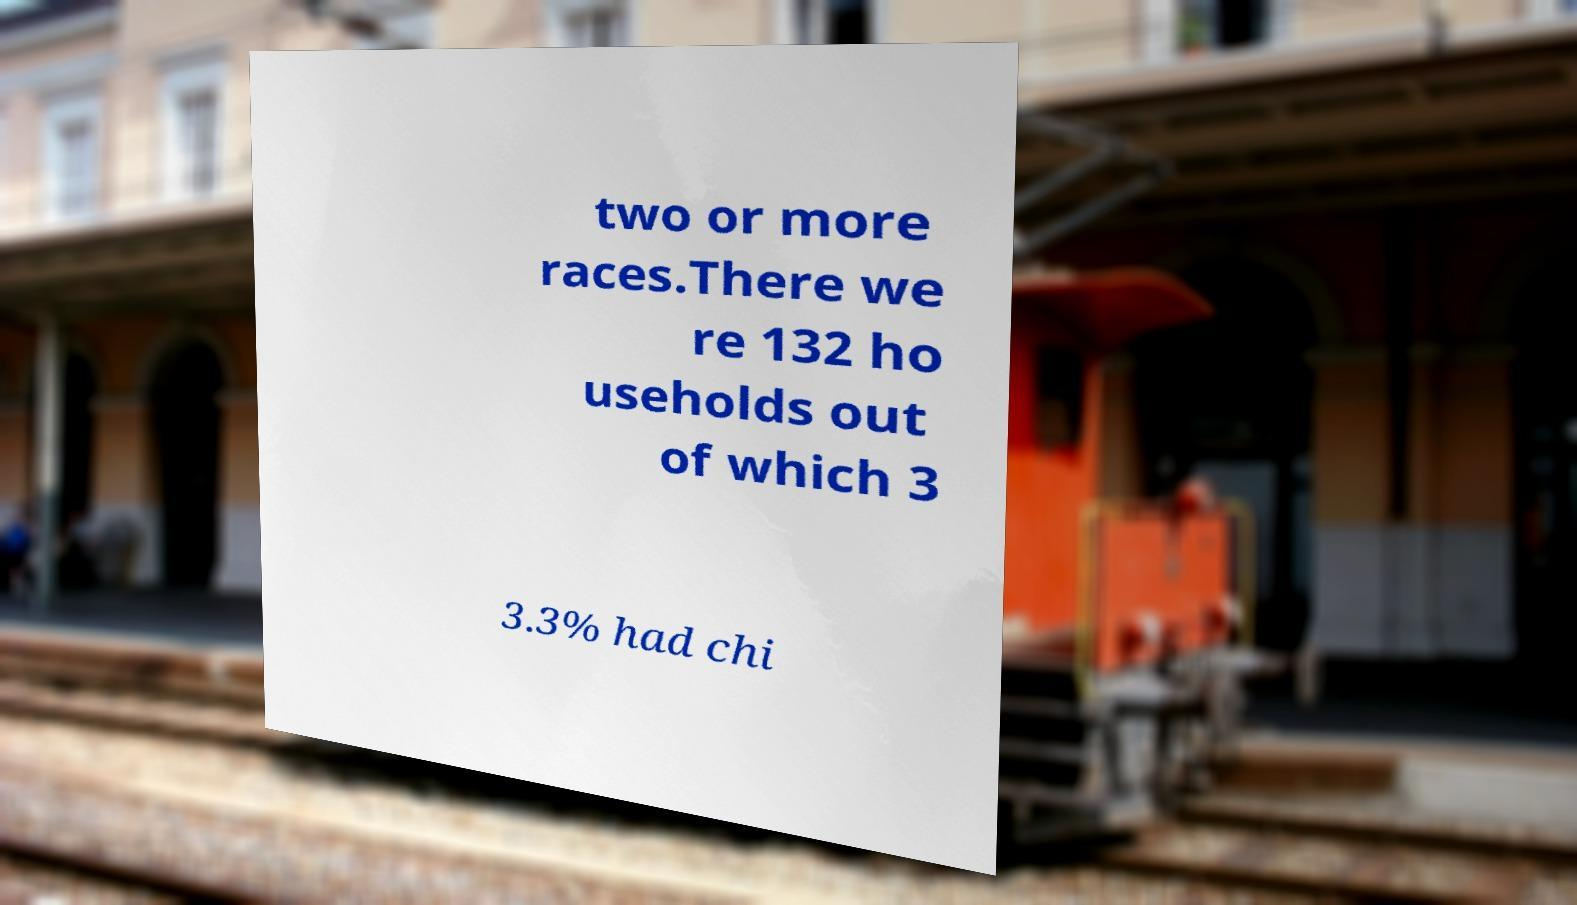Could you extract and type out the text from this image? two or more races.There we re 132 ho useholds out of which 3 3.3% had chi 